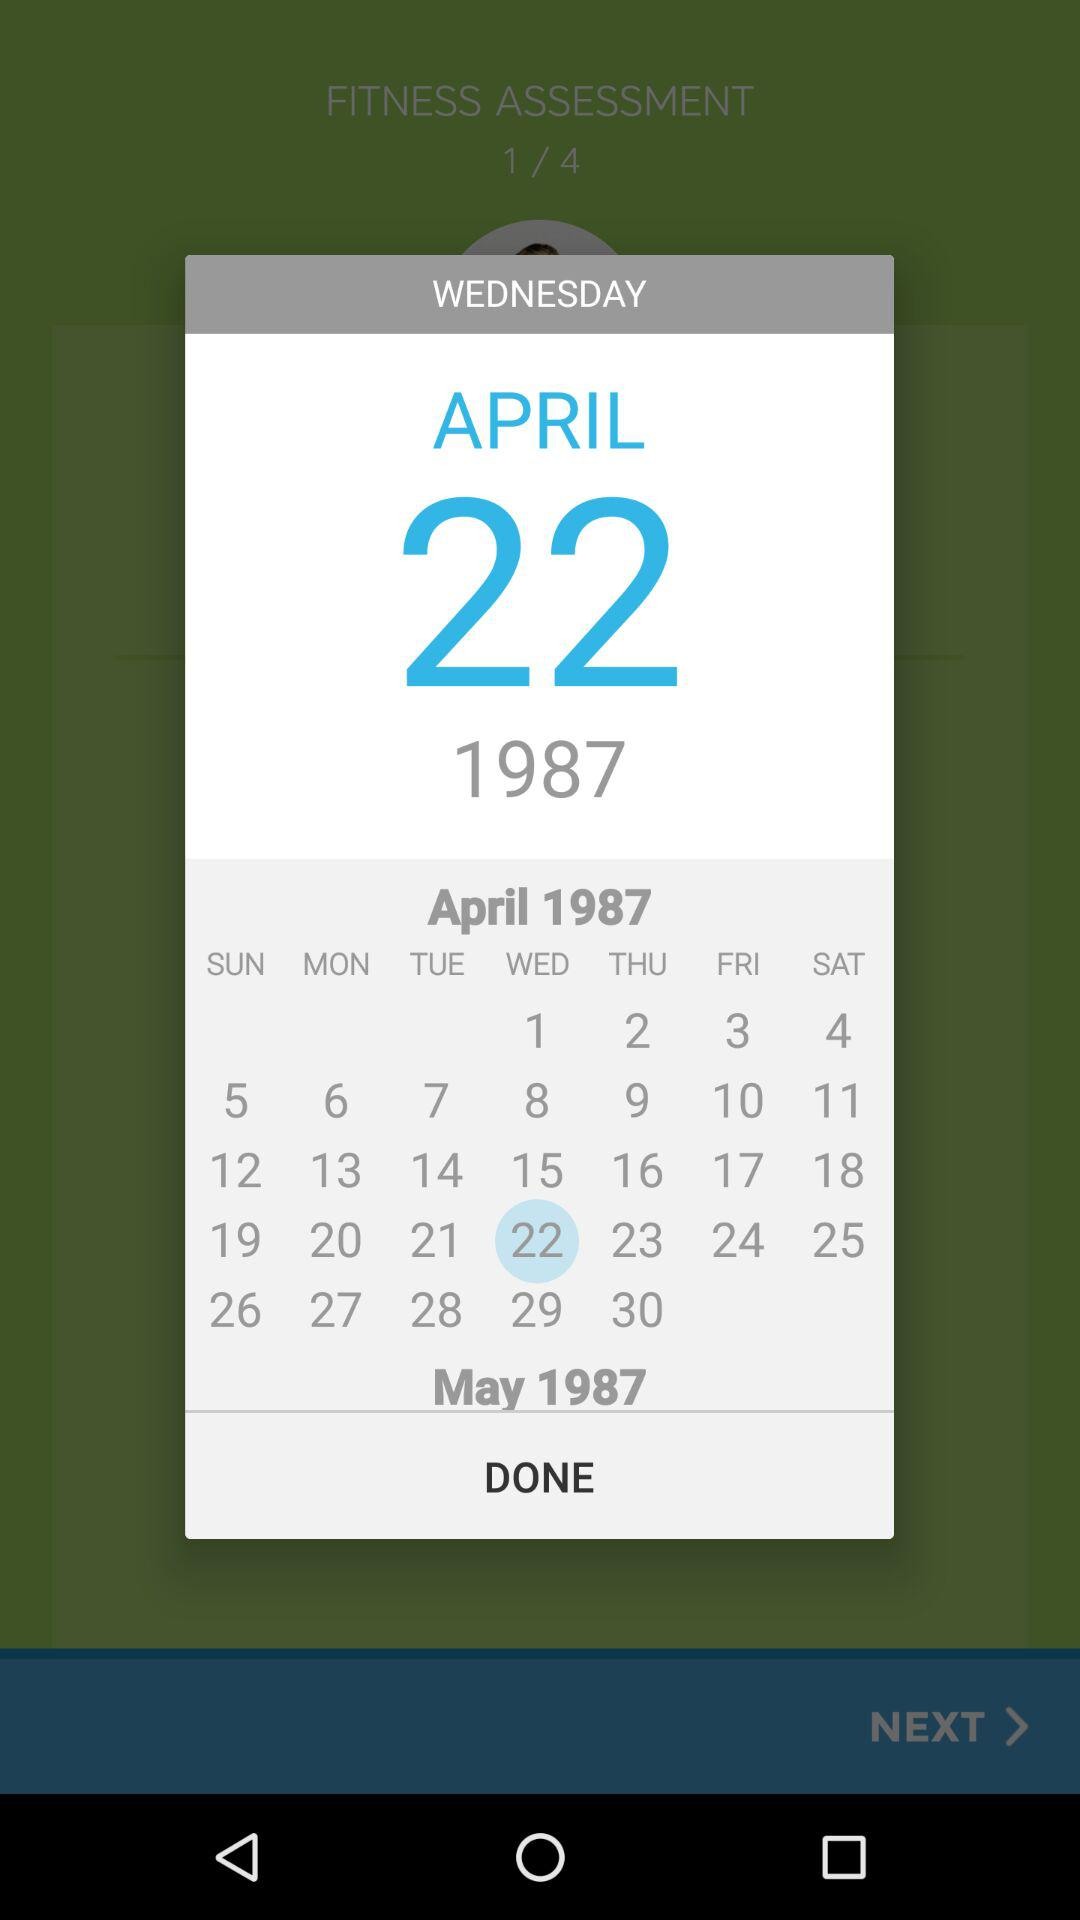What is the day on April 22, 1987? The day is Wednesday. 